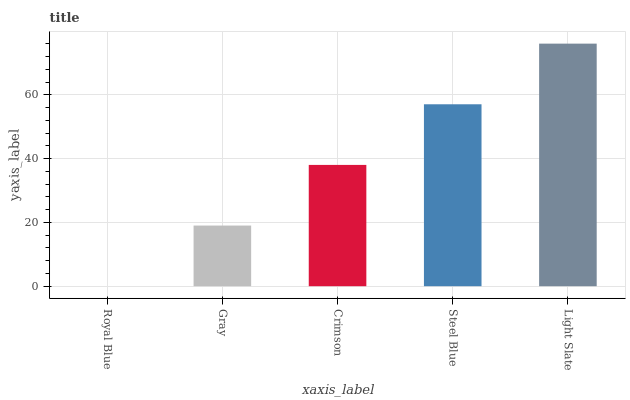Is Royal Blue the minimum?
Answer yes or no. Yes. Is Light Slate the maximum?
Answer yes or no. Yes. Is Gray the minimum?
Answer yes or no. No. Is Gray the maximum?
Answer yes or no. No. Is Gray greater than Royal Blue?
Answer yes or no. Yes. Is Royal Blue less than Gray?
Answer yes or no. Yes. Is Royal Blue greater than Gray?
Answer yes or no. No. Is Gray less than Royal Blue?
Answer yes or no. No. Is Crimson the high median?
Answer yes or no. Yes. Is Crimson the low median?
Answer yes or no. Yes. Is Light Slate the high median?
Answer yes or no. No. Is Gray the low median?
Answer yes or no. No. 